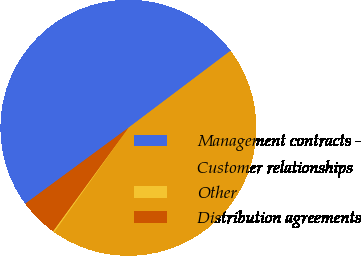<chart> <loc_0><loc_0><loc_500><loc_500><pie_chart><fcel>Management contracts -<fcel>Customer relationships<fcel>Other<fcel>Distribution agreements<nl><fcel>49.82%<fcel>45.12%<fcel>0.18%<fcel>4.88%<nl></chart> 